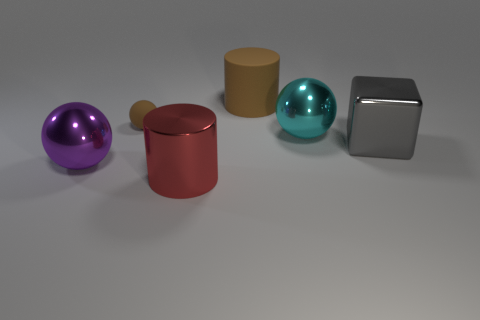Are there any other things that have the same size as the brown sphere?
Your response must be concise. No. What size is the matte ball that is the same color as the rubber cylinder?
Keep it short and to the point. Small. There is a large shiny thing behind the gray metal thing; is it the same color as the big cylinder that is in front of the gray cube?
Provide a short and direct response. No. How big is the brown ball?
Give a very brief answer. Small. How many tiny objects are brown balls or brown matte objects?
Offer a very short reply. 1. What color is the other rubber cylinder that is the same size as the red cylinder?
Your response must be concise. Brown. How many other things are the same shape as the large gray thing?
Your answer should be compact. 0. Is there another gray cube that has the same material as the gray cube?
Make the answer very short. No. Is the brown thing that is in front of the big brown object made of the same material as the object that is behind the small matte object?
Your answer should be very brief. Yes. What number of big gray shiny things are there?
Your answer should be very brief. 1. 